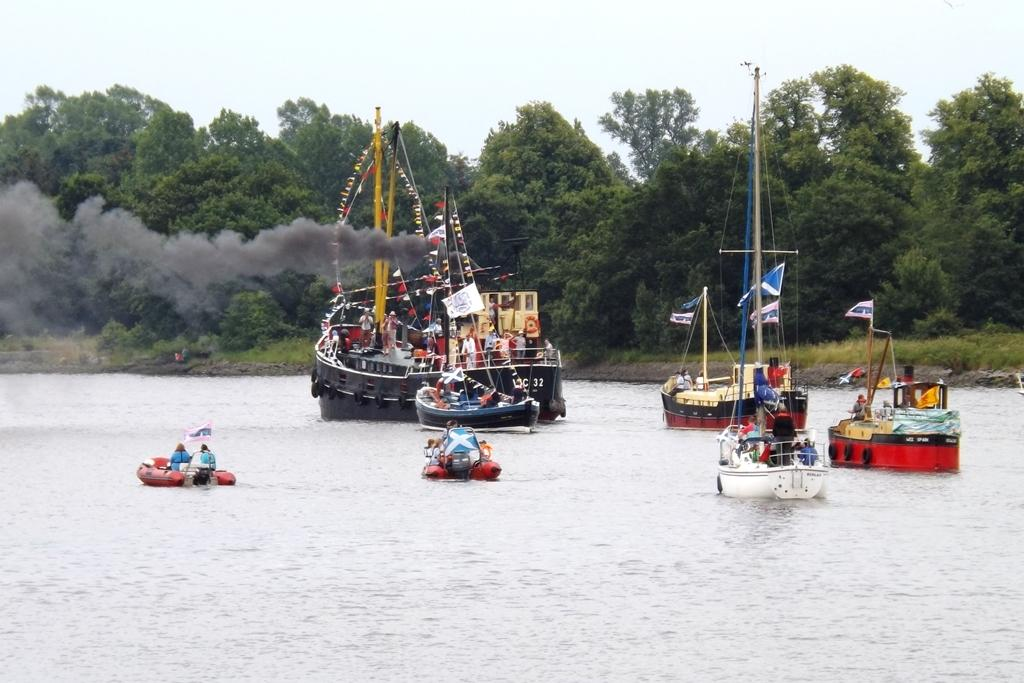Who or what can be seen in the image? There are people in the image. What structures are present in the image? There are poles and flags in the image. Are there any boats in the image? Yes, there are poles on boats in the image. Where are the boats located? The boats are on the water in the image. What can be seen in the background of the image? There are trees and the sky visible in the background of the image. Who is the owner of the sea in the image? There is no sea present in the image, and therefore no owner can be identified. Can you tell me the name of the actor playing the role of the flag in the image? There are no actors or roles in the image; it features people, poles, flags, and boats. 